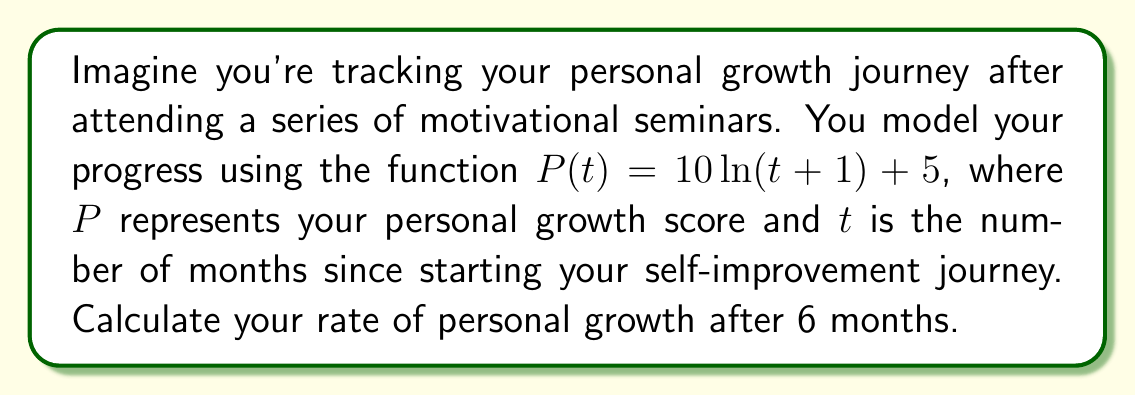Help me with this question. To solve this problem, we need to find the rate of change of the personal growth function $P(t)$ at $t = 6$ months. This can be done using derivatives.

1) First, let's find the derivative of $P(t)$:
   
   $P(t) = 10\ln(t+1) + 5$
   
   Using the chain rule, we get:
   
   $$\frac{dP}{dt} = 10 \cdot \frac{1}{t+1} \cdot \frac{d}{dt}(t+1) = \frac{10}{t+1}$$

2) Now that we have the derivative, we can find the rate of change at any given time by plugging in the value of $t$.

3) We want to know the rate of growth after 6 months, so let's substitute $t = 6$:

   $$\frac{dP}{dt}\bigg|_{t=6} = \frac{10}{6+1} = \frac{10}{7} \approx 1.43$$

This means that after 6 months, your personal growth score is increasing at a rate of approximately 1.43 points per month.
Answer: $\frac{10}{7}$ or approximately 1.43 points per month 